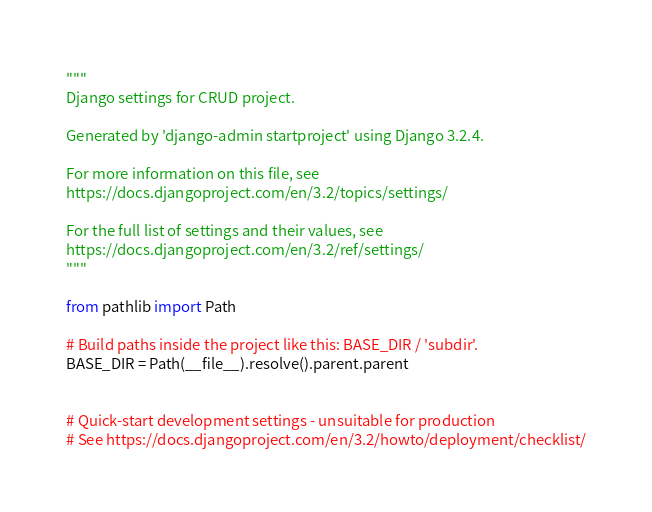Convert code to text. <code><loc_0><loc_0><loc_500><loc_500><_Python_>"""
Django settings for CRUD project.

Generated by 'django-admin startproject' using Django 3.2.4.

For more information on this file, see
https://docs.djangoproject.com/en/3.2/topics/settings/

For the full list of settings and their values, see
https://docs.djangoproject.com/en/3.2/ref/settings/
"""

from pathlib import Path

# Build paths inside the project like this: BASE_DIR / 'subdir'.
BASE_DIR = Path(__file__).resolve().parent.parent


# Quick-start development settings - unsuitable for production
# See https://docs.djangoproject.com/en/3.2/howto/deployment/checklist/
</code> 